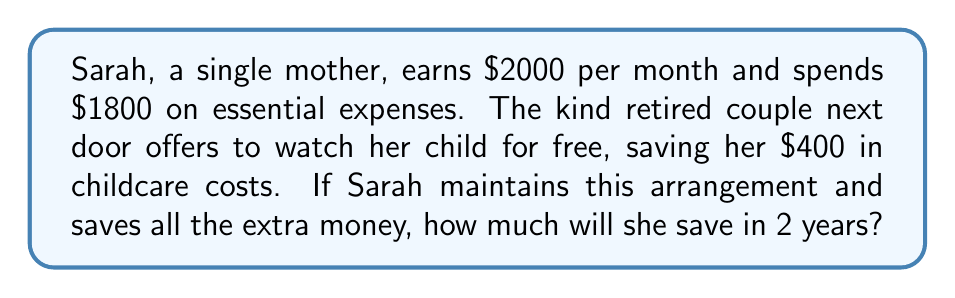Solve this math problem. Let's break this down step-by-step:

1. Calculate Sarah's monthly savings:
   - Original income: $2000
   - Original expenses: $1800
   - Childcare savings: $400
   - New monthly expenses: $1800 - $400 = $1400
   - Monthly savings: $2000 - $1400 = $600

2. Calculate the savings for 2 years:
   - Number of months in 2 years: 24
   - Total savings: $600 × 24 = $14,400

Therefore, the linear equation for Sarah's savings over time can be expressed as:

$$S = 600m$$

Where $S$ is the total savings and $m$ is the number of months.

For 24 months:
$$S = 600 \times 24 = 14,400$$
Answer: $14,400 